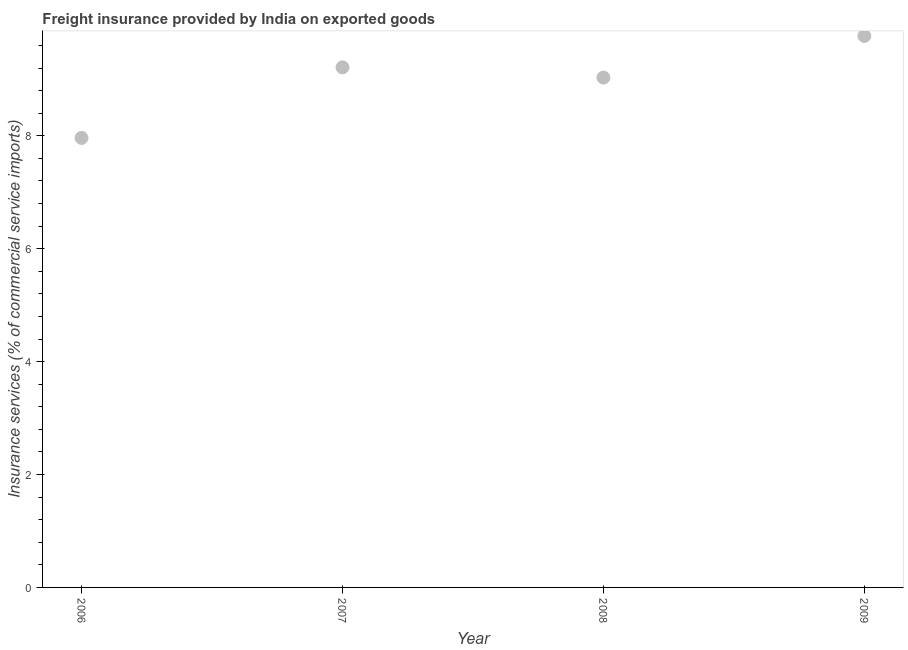What is the freight insurance in 2009?
Offer a terse response. 9.77. Across all years, what is the maximum freight insurance?
Your answer should be very brief. 9.77. Across all years, what is the minimum freight insurance?
Give a very brief answer. 7.96. What is the sum of the freight insurance?
Offer a very short reply. 35.97. What is the difference between the freight insurance in 2006 and 2007?
Give a very brief answer. -1.25. What is the average freight insurance per year?
Make the answer very short. 8.99. What is the median freight insurance?
Ensure brevity in your answer.  9.12. In how many years, is the freight insurance greater than 2.4 %?
Offer a very short reply. 4. What is the ratio of the freight insurance in 2007 to that in 2008?
Offer a terse response. 1.02. Is the freight insurance in 2007 less than that in 2009?
Keep it short and to the point. Yes. What is the difference between the highest and the second highest freight insurance?
Your response must be concise. 0.56. Is the sum of the freight insurance in 2006 and 2009 greater than the maximum freight insurance across all years?
Provide a succinct answer. Yes. What is the difference between the highest and the lowest freight insurance?
Provide a short and direct response. 1.81. Does the freight insurance monotonically increase over the years?
Provide a short and direct response. No. How many years are there in the graph?
Your answer should be very brief. 4. Does the graph contain any zero values?
Provide a succinct answer. No. What is the title of the graph?
Provide a succinct answer. Freight insurance provided by India on exported goods . What is the label or title of the X-axis?
Offer a very short reply. Year. What is the label or title of the Y-axis?
Ensure brevity in your answer.  Insurance services (% of commercial service imports). What is the Insurance services (% of commercial service imports) in 2006?
Offer a very short reply. 7.96. What is the Insurance services (% of commercial service imports) in 2007?
Your answer should be very brief. 9.21. What is the Insurance services (% of commercial service imports) in 2008?
Your answer should be very brief. 9.03. What is the Insurance services (% of commercial service imports) in 2009?
Offer a terse response. 9.77. What is the difference between the Insurance services (% of commercial service imports) in 2006 and 2007?
Provide a short and direct response. -1.25. What is the difference between the Insurance services (% of commercial service imports) in 2006 and 2008?
Your response must be concise. -1.07. What is the difference between the Insurance services (% of commercial service imports) in 2006 and 2009?
Your answer should be very brief. -1.81. What is the difference between the Insurance services (% of commercial service imports) in 2007 and 2008?
Make the answer very short. 0.18. What is the difference between the Insurance services (% of commercial service imports) in 2007 and 2009?
Keep it short and to the point. -0.56. What is the difference between the Insurance services (% of commercial service imports) in 2008 and 2009?
Your answer should be compact. -0.74. What is the ratio of the Insurance services (% of commercial service imports) in 2006 to that in 2007?
Keep it short and to the point. 0.86. What is the ratio of the Insurance services (% of commercial service imports) in 2006 to that in 2008?
Give a very brief answer. 0.88. What is the ratio of the Insurance services (% of commercial service imports) in 2006 to that in 2009?
Offer a very short reply. 0.81. What is the ratio of the Insurance services (% of commercial service imports) in 2007 to that in 2009?
Ensure brevity in your answer.  0.94. What is the ratio of the Insurance services (% of commercial service imports) in 2008 to that in 2009?
Ensure brevity in your answer.  0.92. 